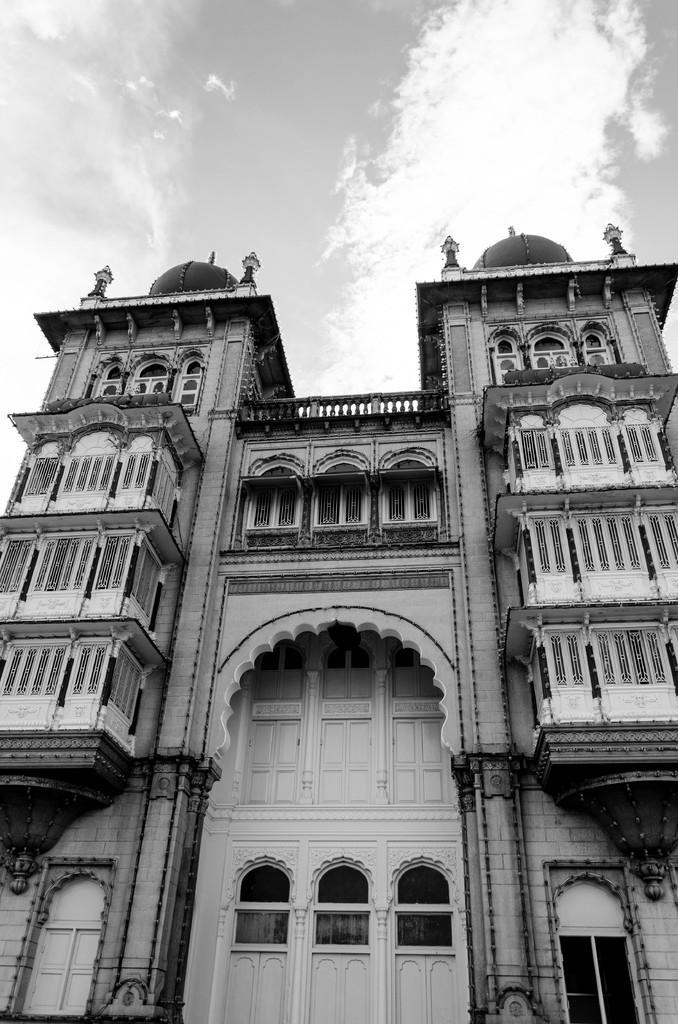Can you describe this image briefly? In the foreground of this black and white image, there is a building. At the top, there is the sky and the cloud. 